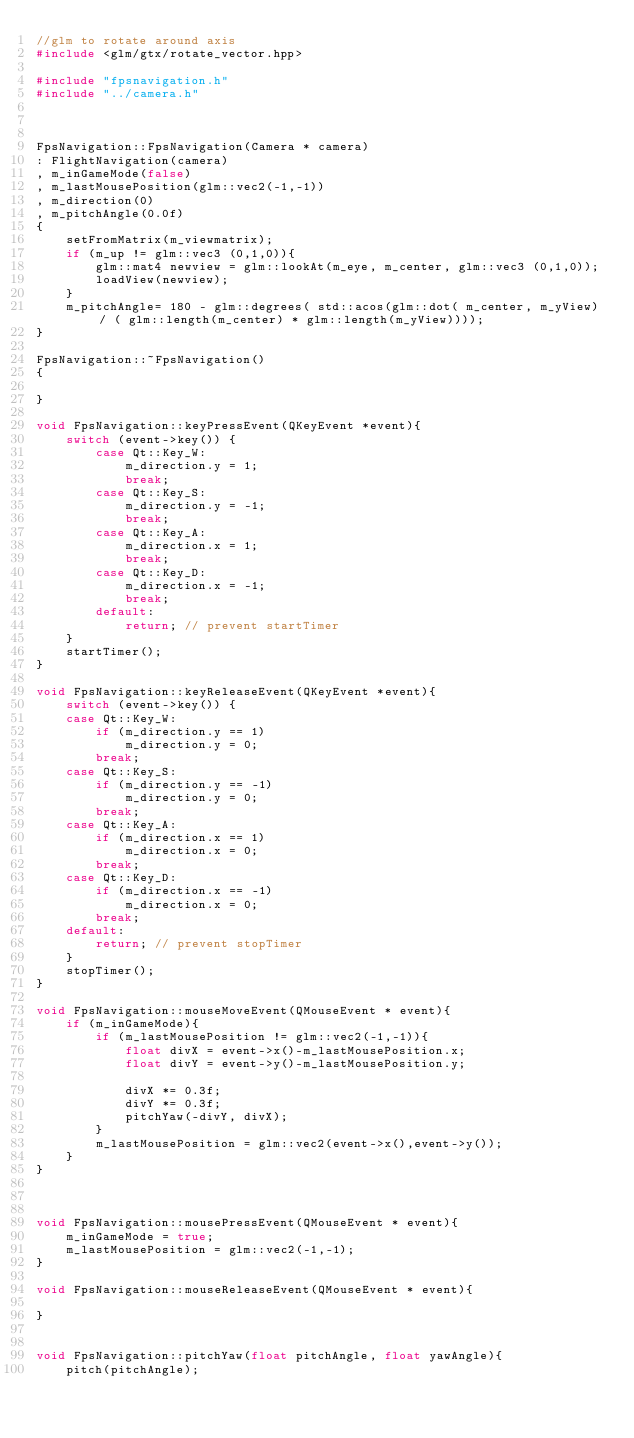<code> <loc_0><loc_0><loc_500><loc_500><_C++_>//glm to rotate around axis
#include <glm/gtx/rotate_vector.hpp>

#include "fpsnavigation.h"
#include "../camera.h"



FpsNavigation::FpsNavigation(Camera * camera)
: FlightNavigation(camera)
, m_inGameMode(false)
, m_lastMousePosition(glm::vec2(-1,-1))
, m_direction(0)
, m_pitchAngle(0.0f)
{
    setFromMatrix(m_viewmatrix);
    if (m_up != glm::vec3 (0,1,0)){
        glm::mat4 newview = glm::lookAt(m_eye, m_center, glm::vec3 (0,1,0));
        loadView(newview);
    }
    m_pitchAngle= 180 - glm::degrees( std::acos(glm::dot( m_center, m_yView) / ( glm::length(m_center) * glm::length(m_yView))));
}

FpsNavigation::~FpsNavigation()
{
    
}

void FpsNavigation::keyPressEvent(QKeyEvent *event){
    switch (event->key()) {
        case Qt::Key_W:
            m_direction.y = 1;
            break;
        case Qt::Key_S:
            m_direction.y = -1;
            break;
        case Qt::Key_A:
            m_direction.x = 1;
            break;
        case Qt::Key_D:
            m_direction.x = -1;
            break;
        default:
            return; // prevent startTimer
    }
    startTimer();
}

void FpsNavigation::keyReleaseEvent(QKeyEvent *event){
    switch (event->key()) {
    case Qt::Key_W:
        if (m_direction.y == 1)
            m_direction.y = 0;
        break;
    case Qt::Key_S:
        if (m_direction.y == -1)
            m_direction.y = 0;
        break;
    case Qt::Key_A:
        if (m_direction.x == 1)
            m_direction.x = 0;
        break;
    case Qt::Key_D:
        if (m_direction.x == -1)
            m_direction.x = 0;
        break;
    default:
        return; // prevent stopTimer
    }
    stopTimer();
}

void FpsNavigation::mouseMoveEvent(QMouseEvent * event){
    if (m_inGameMode){
        if (m_lastMousePosition != glm::vec2(-1,-1)){
            float divX = event->x()-m_lastMousePosition.x;
            float divY = event->y()-m_lastMousePosition.y;
            
            divX *= 0.3f;
            divY *= 0.3f;
            pitchYaw(-divY, divX);
        }
        m_lastMousePosition = glm::vec2(event->x(),event->y());
    }
}



void FpsNavigation::mousePressEvent(QMouseEvent * event){
    m_inGameMode = true;
    m_lastMousePosition = glm::vec2(-1,-1);
}

void FpsNavigation::mouseReleaseEvent(QMouseEvent * event){
    
}


void FpsNavigation::pitchYaw(float pitchAngle, float yawAngle){
    pitch(pitchAngle);</code> 